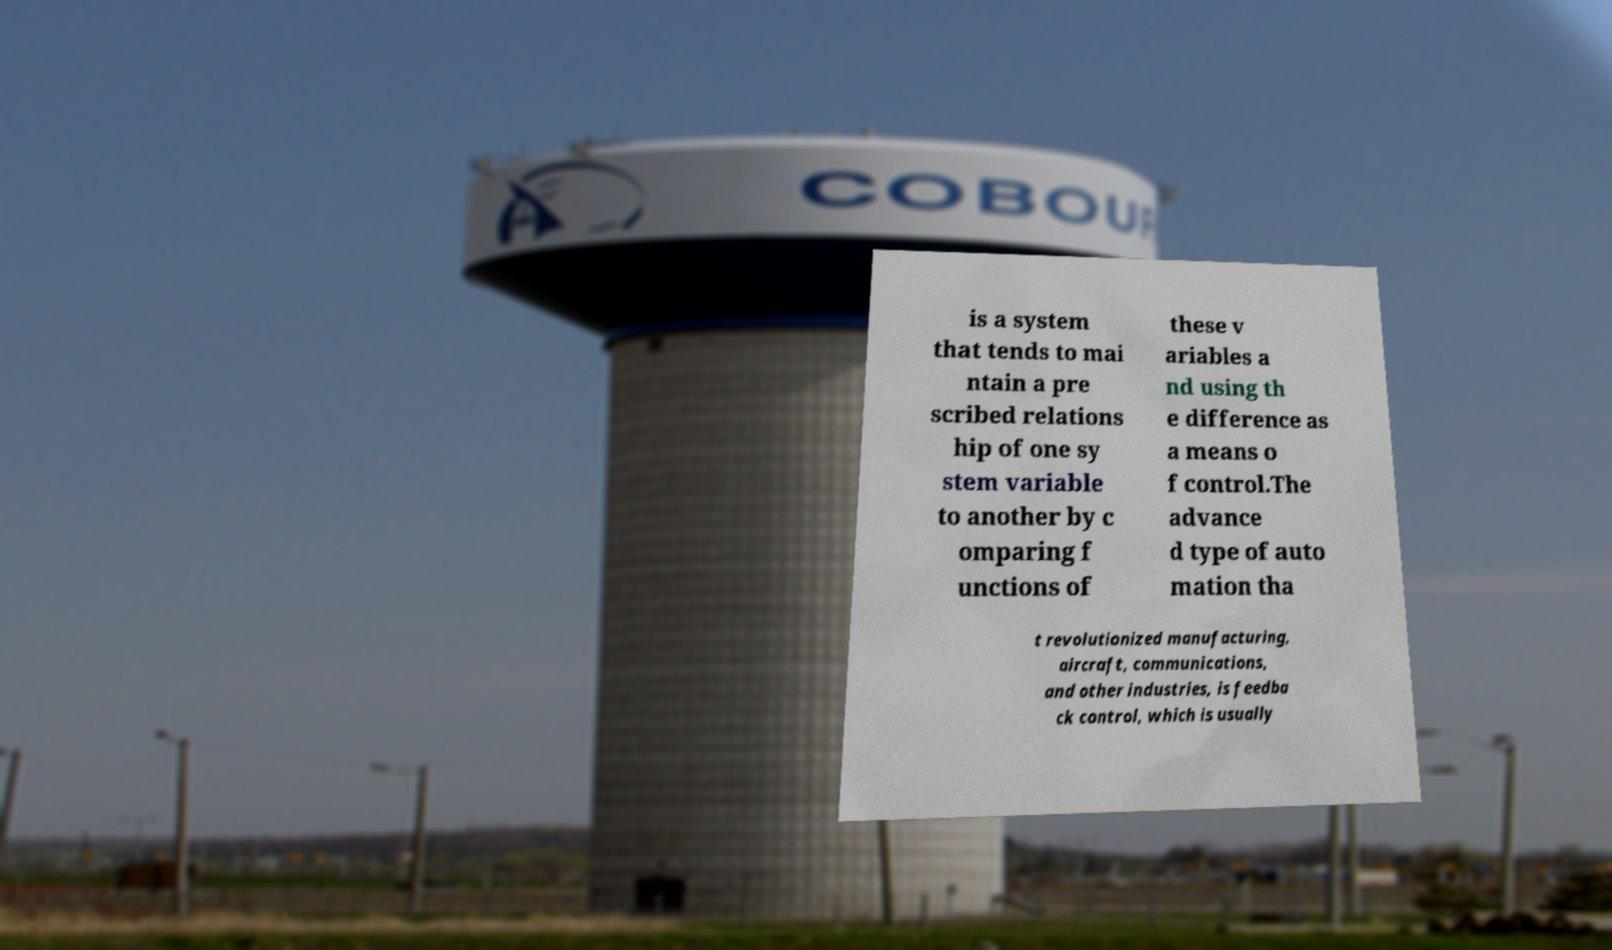There's text embedded in this image that I need extracted. Can you transcribe it verbatim? is a system that tends to mai ntain a pre scribed relations hip of one sy stem variable to another by c omparing f unctions of these v ariables a nd using th e difference as a means o f control.The advance d type of auto mation tha t revolutionized manufacturing, aircraft, communications, and other industries, is feedba ck control, which is usually 